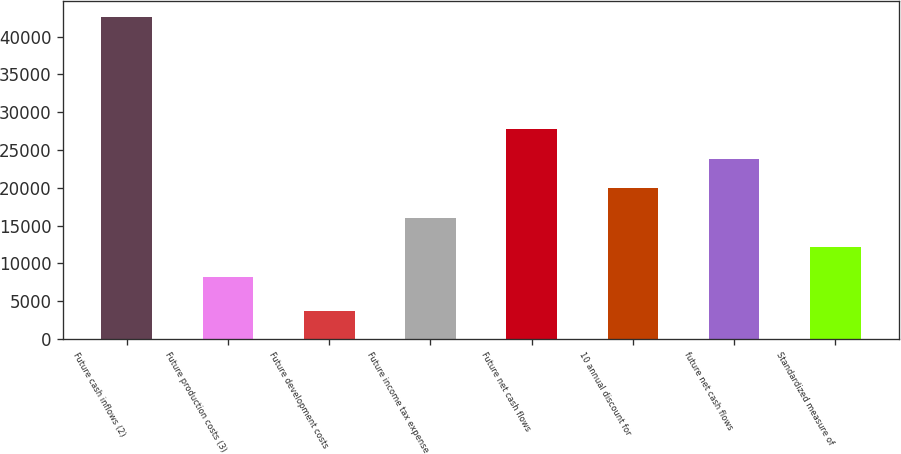Convert chart to OTSL. <chart><loc_0><loc_0><loc_500><loc_500><bar_chart><fcel>Future cash inflows (2)<fcel>Future production costs (3)<fcel>Future development costs<fcel>Future income tax expense<fcel>Future net cash flows<fcel>10 annual discount for<fcel>future net cash flows<fcel>Standardized measure of<nl><fcel>42601<fcel>8253<fcel>3653<fcel>16042.6<fcel>27727<fcel>19937.4<fcel>23832.2<fcel>12147.8<nl></chart> 